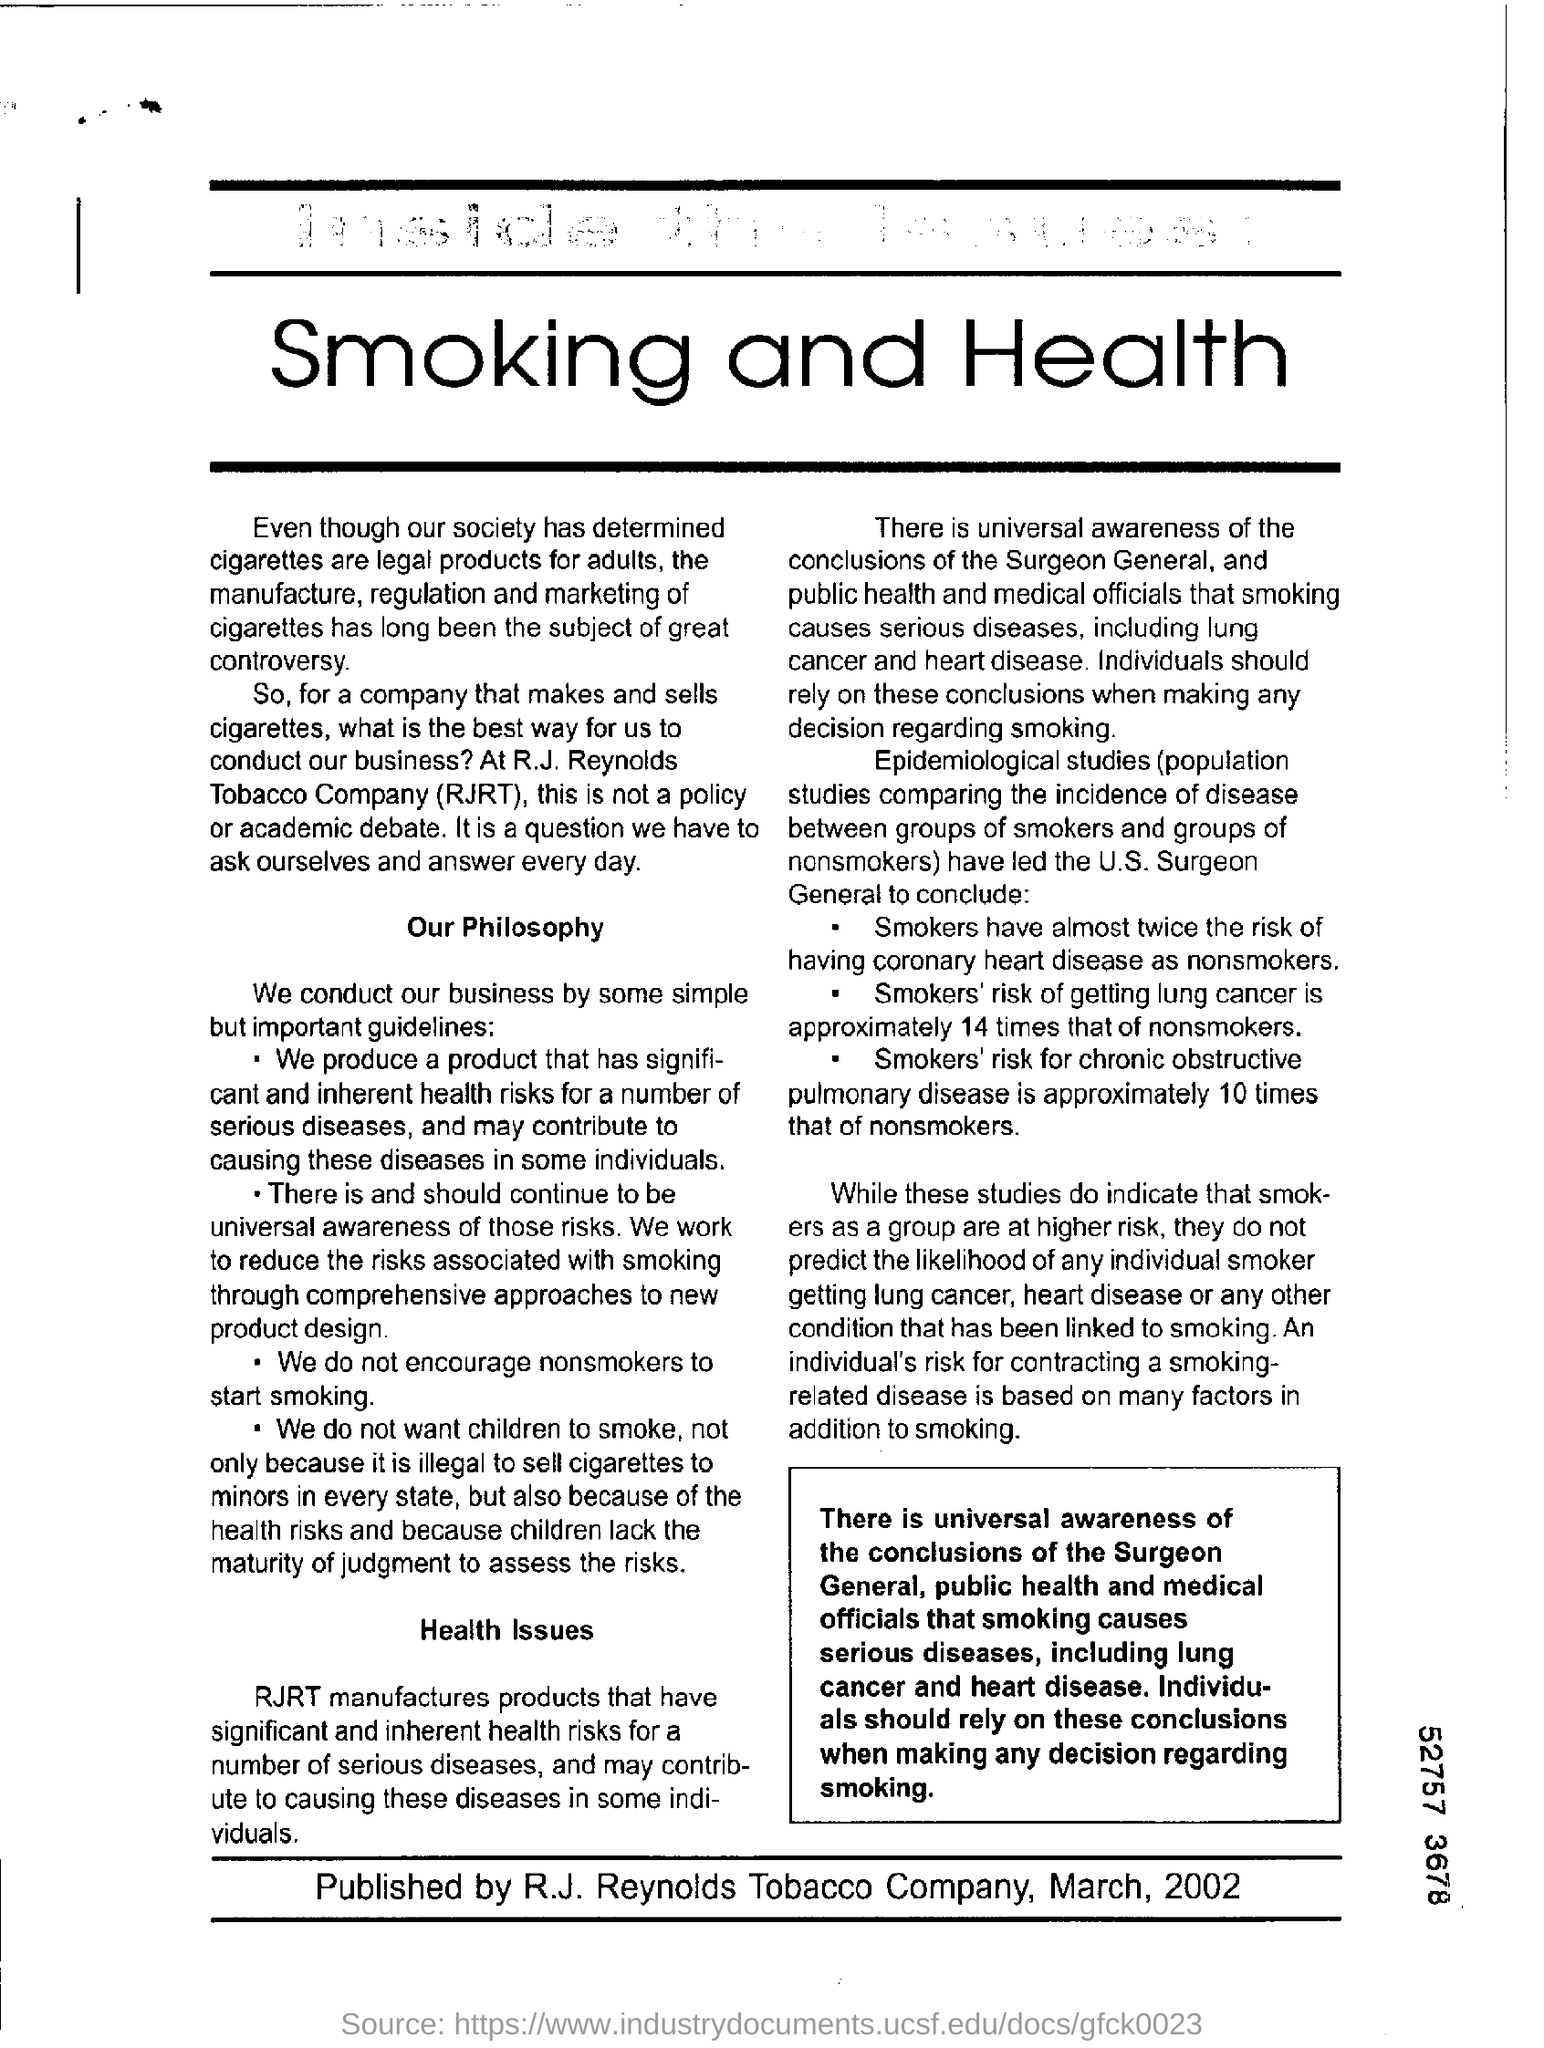List a handful of essential elements in this visual. The heading of the page is "Smoking and Health. 